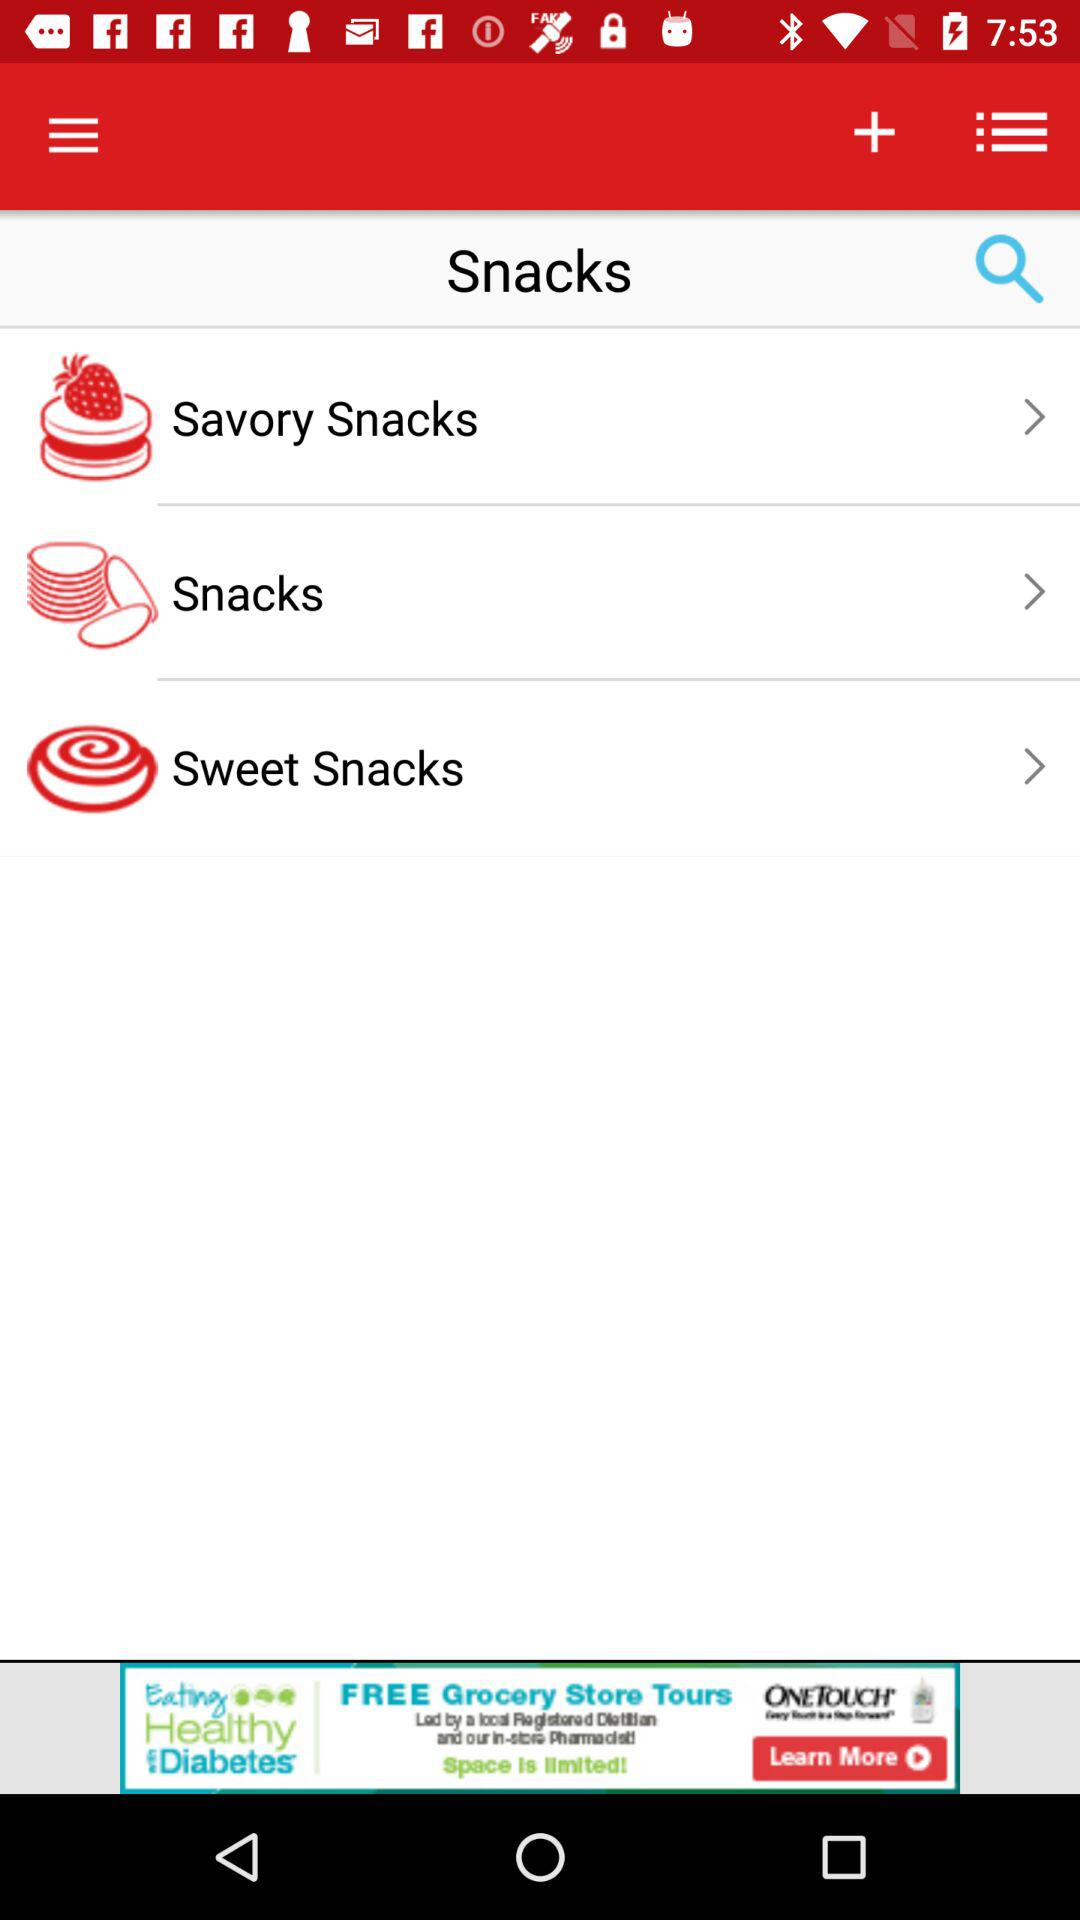How many savory snacks are there?
When the provided information is insufficient, respond with <no answer>. <no answer> 